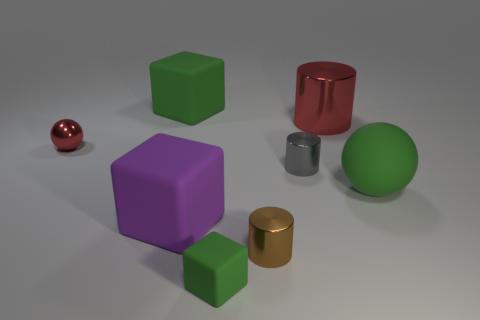There is a tiny red sphere that is in front of the big green matte object behind the big metal object; is there a metal sphere that is to the right of it?
Keep it short and to the point. No. What number of objects are tiny metal things to the left of the small matte object or objects that are in front of the big purple thing?
Give a very brief answer. 3. Do the big green thing that is on the right side of the tiny matte thing and the big purple object have the same material?
Give a very brief answer. Yes. There is a object that is to the right of the small matte object and to the left of the tiny gray metallic cylinder; what is its material?
Offer a very short reply. Metal. What is the color of the large thing in front of the large green thing that is in front of the tiny red metal ball?
Offer a very short reply. Purple. There is a large green object that is the same shape as the tiny red object; what material is it?
Your response must be concise. Rubber. What color is the metal cylinder that is behind the red metal thing that is left of the green rubber cube that is behind the tiny green rubber block?
Your answer should be compact. Red. How many things are red things or brown metallic things?
Keep it short and to the point. 3. What number of other gray things are the same shape as the tiny matte object?
Keep it short and to the point. 0. Do the tiny green object and the cube behind the tiny red metallic ball have the same material?
Keep it short and to the point. Yes. 